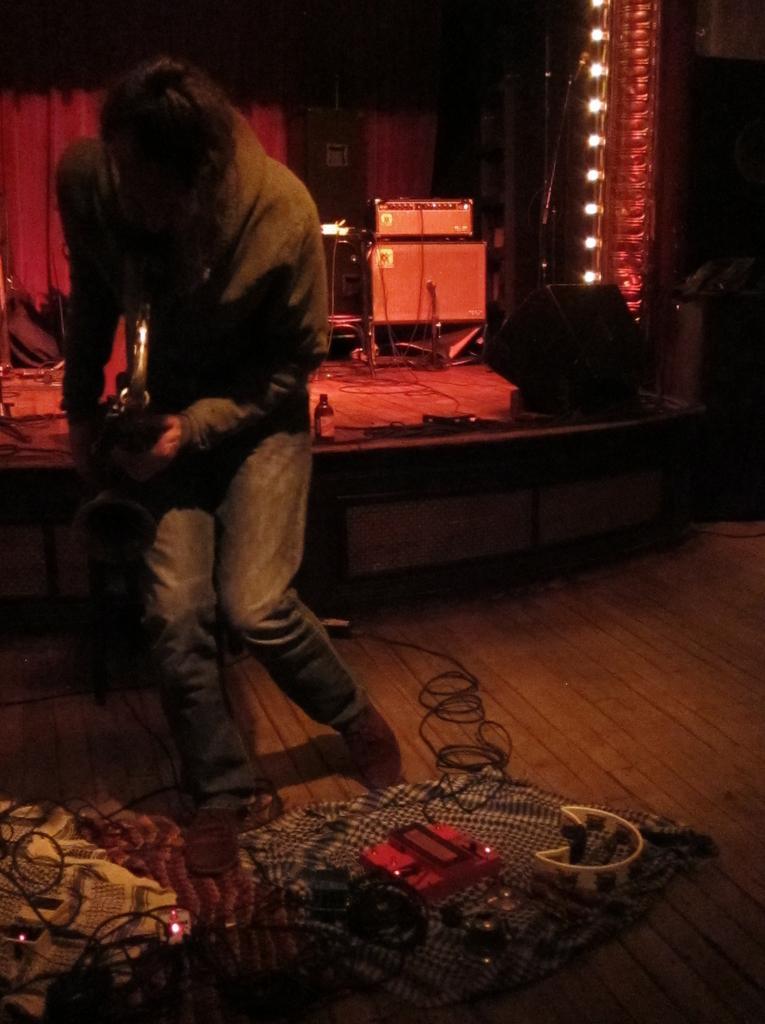Describe this image in one or two sentences. In this image there is a person playing guitar, in front of the person there are some cables and some other objects on the floor, behind the person on the stage there are some musical instruments, speakers and some other objects, behind the stage there is a curtain and beside the stage there are lights decorated on the wall. 